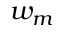<formula> <loc_0><loc_0><loc_500><loc_500>w _ { m }</formula> 